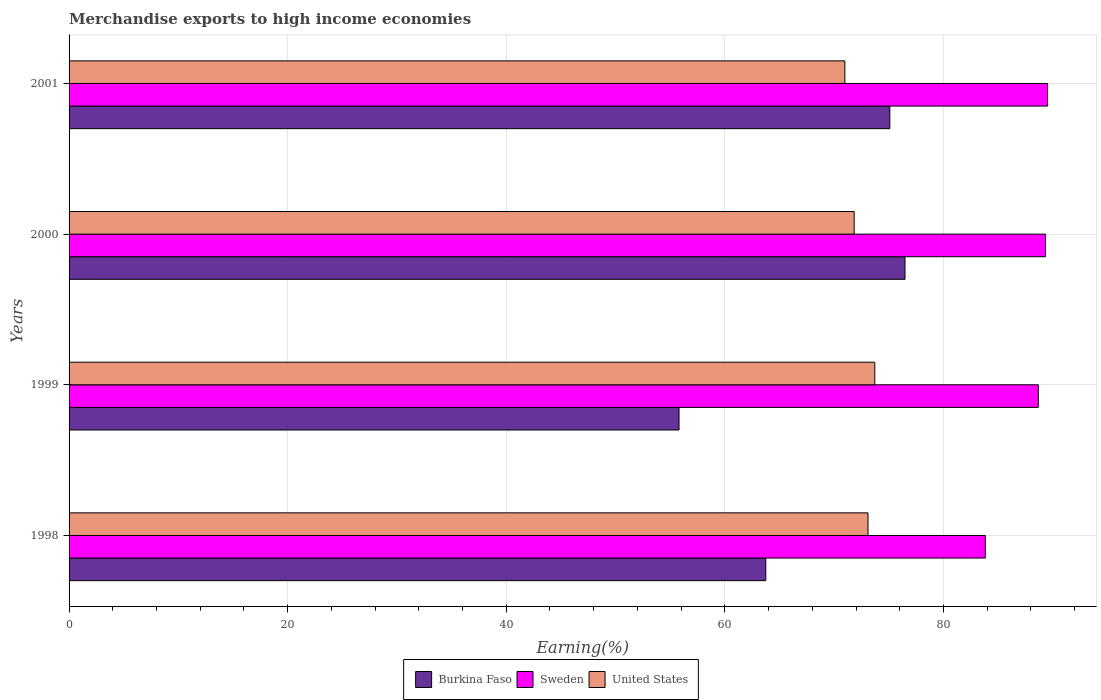What is the label of the 1st group of bars from the top?
Your answer should be very brief. 2001. What is the percentage of amount earned from merchandise exports in United States in 2001?
Give a very brief answer. 70.98. Across all years, what is the maximum percentage of amount earned from merchandise exports in Burkina Faso?
Provide a succinct answer. 76.48. Across all years, what is the minimum percentage of amount earned from merchandise exports in Burkina Faso?
Give a very brief answer. 55.81. In which year was the percentage of amount earned from merchandise exports in Sweden minimum?
Keep it short and to the point. 1998. What is the total percentage of amount earned from merchandise exports in Burkina Faso in the graph?
Give a very brief answer. 271.13. What is the difference between the percentage of amount earned from merchandise exports in United States in 2000 and that in 2001?
Provide a short and direct response. 0.85. What is the difference between the percentage of amount earned from merchandise exports in United States in 2000 and the percentage of amount earned from merchandise exports in Sweden in 2001?
Your answer should be very brief. -17.69. What is the average percentage of amount earned from merchandise exports in Burkina Faso per year?
Keep it short and to the point. 67.78. In the year 2000, what is the difference between the percentage of amount earned from merchandise exports in Burkina Faso and percentage of amount earned from merchandise exports in Sweden?
Offer a very short reply. -12.85. What is the ratio of the percentage of amount earned from merchandise exports in Sweden in 2000 to that in 2001?
Your answer should be compact. 1. Is the percentage of amount earned from merchandise exports in Sweden in 1998 less than that in 1999?
Ensure brevity in your answer.  Yes. Is the difference between the percentage of amount earned from merchandise exports in Burkina Faso in 1998 and 2000 greater than the difference between the percentage of amount earned from merchandise exports in Sweden in 1998 and 2000?
Give a very brief answer. No. What is the difference between the highest and the second highest percentage of amount earned from merchandise exports in Burkina Faso?
Provide a short and direct response. 1.39. What is the difference between the highest and the lowest percentage of amount earned from merchandise exports in Burkina Faso?
Make the answer very short. 20.68. In how many years, is the percentage of amount earned from merchandise exports in Burkina Faso greater than the average percentage of amount earned from merchandise exports in Burkina Faso taken over all years?
Give a very brief answer. 2. What does the 1st bar from the top in 2001 represents?
Keep it short and to the point. United States. What does the 2nd bar from the bottom in 2000 represents?
Offer a very short reply. Sweden. What is the difference between two consecutive major ticks on the X-axis?
Keep it short and to the point. 20. Are the values on the major ticks of X-axis written in scientific E-notation?
Provide a short and direct response. No. How many legend labels are there?
Provide a succinct answer. 3. How are the legend labels stacked?
Offer a terse response. Horizontal. What is the title of the graph?
Ensure brevity in your answer.  Merchandise exports to high income economies. Does "Venezuela" appear as one of the legend labels in the graph?
Your answer should be very brief. No. What is the label or title of the X-axis?
Your response must be concise. Earning(%). What is the Earning(%) in Burkina Faso in 1998?
Provide a succinct answer. 63.75. What is the Earning(%) of Sweden in 1998?
Your response must be concise. 83.83. What is the Earning(%) of United States in 1998?
Provide a short and direct response. 73.1. What is the Earning(%) in Burkina Faso in 1999?
Give a very brief answer. 55.81. What is the Earning(%) of Sweden in 1999?
Ensure brevity in your answer.  88.68. What is the Earning(%) of United States in 1999?
Provide a succinct answer. 73.72. What is the Earning(%) of Burkina Faso in 2000?
Offer a terse response. 76.48. What is the Earning(%) in Sweden in 2000?
Give a very brief answer. 89.33. What is the Earning(%) of United States in 2000?
Your response must be concise. 71.83. What is the Earning(%) of Burkina Faso in 2001?
Provide a short and direct response. 75.09. What is the Earning(%) in Sweden in 2001?
Your response must be concise. 89.53. What is the Earning(%) of United States in 2001?
Offer a terse response. 70.98. Across all years, what is the maximum Earning(%) in Burkina Faso?
Your response must be concise. 76.48. Across all years, what is the maximum Earning(%) in Sweden?
Ensure brevity in your answer.  89.53. Across all years, what is the maximum Earning(%) of United States?
Your answer should be very brief. 73.72. Across all years, what is the minimum Earning(%) of Burkina Faso?
Offer a terse response. 55.81. Across all years, what is the minimum Earning(%) of Sweden?
Ensure brevity in your answer.  83.83. Across all years, what is the minimum Earning(%) in United States?
Give a very brief answer. 70.98. What is the total Earning(%) in Burkina Faso in the graph?
Give a very brief answer. 271.13. What is the total Earning(%) of Sweden in the graph?
Make the answer very short. 351.37. What is the total Earning(%) of United States in the graph?
Your answer should be compact. 289.63. What is the difference between the Earning(%) in Burkina Faso in 1998 and that in 1999?
Your answer should be compact. 7.94. What is the difference between the Earning(%) of Sweden in 1998 and that in 1999?
Provide a succinct answer. -4.84. What is the difference between the Earning(%) in United States in 1998 and that in 1999?
Give a very brief answer. -0.62. What is the difference between the Earning(%) in Burkina Faso in 1998 and that in 2000?
Your response must be concise. -12.74. What is the difference between the Earning(%) in Sweden in 1998 and that in 2000?
Offer a very short reply. -5.5. What is the difference between the Earning(%) of United States in 1998 and that in 2000?
Offer a terse response. 1.26. What is the difference between the Earning(%) of Burkina Faso in 1998 and that in 2001?
Provide a short and direct response. -11.35. What is the difference between the Earning(%) of Sweden in 1998 and that in 2001?
Make the answer very short. -5.69. What is the difference between the Earning(%) in United States in 1998 and that in 2001?
Ensure brevity in your answer.  2.12. What is the difference between the Earning(%) in Burkina Faso in 1999 and that in 2000?
Offer a very short reply. -20.68. What is the difference between the Earning(%) of Sweden in 1999 and that in 2000?
Keep it short and to the point. -0.66. What is the difference between the Earning(%) of United States in 1999 and that in 2000?
Keep it short and to the point. 1.89. What is the difference between the Earning(%) of Burkina Faso in 1999 and that in 2001?
Your response must be concise. -19.29. What is the difference between the Earning(%) of Sweden in 1999 and that in 2001?
Give a very brief answer. -0.85. What is the difference between the Earning(%) of United States in 1999 and that in 2001?
Give a very brief answer. 2.74. What is the difference between the Earning(%) of Burkina Faso in 2000 and that in 2001?
Your answer should be compact. 1.39. What is the difference between the Earning(%) of Sweden in 2000 and that in 2001?
Give a very brief answer. -0.19. What is the difference between the Earning(%) of United States in 2000 and that in 2001?
Give a very brief answer. 0.85. What is the difference between the Earning(%) of Burkina Faso in 1998 and the Earning(%) of Sweden in 1999?
Make the answer very short. -24.93. What is the difference between the Earning(%) in Burkina Faso in 1998 and the Earning(%) in United States in 1999?
Your answer should be very brief. -9.97. What is the difference between the Earning(%) in Sweden in 1998 and the Earning(%) in United States in 1999?
Ensure brevity in your answer.  10.11. What is the difference between the Earning(%) in Burkina Faso in 1998 and the Earning(%) in Sweden in 2000?
Keep it short and to the point. -25.59. What is the difference between the Earning(%) of Burkina Faso in 1998 and the Earning(%) of United States in 2000?
Your response must be concise. -8.09. What is the difference between the Earning(%) of Sweden in 1998 and the Earning(%) of United States in 2000?
Keep it short and to the point. 12. What is the difference between the Earning(%) in Burkina Faso in 1998 and the Earning(%) in Sweden in 2001?
Give a very brief answer. -25.78. What is the difference between the Earning(%) in Burkina Faso in 1998 and the Earning(%) in United States in 2001?
Provide a succinct answer. -7.23. What is the difference between the Earning(%) in Sweden in 1998 and the Earning(%) in United States in 2001?
Keep it short and to the point. 12.85. What is the difference between the Earning(%) in Burkina Faso in 1999 and the Earning(%) in Sweden in 2000?
Offer a terse response. -33.53. What is the difference between the Earning(%) of Burkina Faso in 1999 and the Earning(%) of United States in 2000?
Your answer should be very brief. -16.02. What is the difference between the Earning(%) in Sweden in 1999 and the Earning(%) in United States in 2000?
Keep it short and to the point. 16.84. What is the difference between the Earning(%) in Burkina Faso in 1999 and the Earning(%) in Sweden in 2001?
Provide a succinct answer. -33.72. What is the difference between the Earning(%) in Burkina Faso in 1999 and the Earning(%) in United States in 2001?
Provide a short and direct response. -15.17. What is the difference between the Earning(%) of Sweden in 1999 and the Earning(%) of United States in 2001?
Your answer should be compact. 17.7. What is the difference between the Earning(%) in Burkina Faso in 2000 and the Earning(%) in Sweden in 2001?
Keep it short and to the point. -13.04. What is the difference between the Earning(%) of Burkina Faso in 2000 and the Earning(%) of United States in 2001?
Make the answer very short. 5.5. What is the difference between the Earning(%) of Sweden in 2000 and the Earning(%) of United States in 2001?
Provide a succinct answer. 18.35. What is the average Earning(%) of Burkina Faso per year?
Your answer should be very brief. 67.78. What is the average Earning(%) in Sweden per year?
Ensure brevity in your answer.  87.84. What is the average Earning(%) in United States per year?
Offer a very short reply. 72.41. In the year 1998, what is the difference between the Earning(%) of Burkina Faso and Earning(%) of Sweden?
Ensure brevity in your answer.  -20.09. In the year 1998, what is the difference between the Earning(%) of Burkina Faso and Earning(%) of United States?
Provide a short and direct response. -9.35. In the year 1998, what is the difference between the Earning(%) of Sweden and Earning(%) of United States?
Your answer should be compact. 10.74. In the year 1999, what is the difference between the Earning(%) in Burkina Faso and Earning(%) in Sweden?
Provide a succinct answer. -32.87. In the year 1999, what is the difference between the Earning(%) in Burkina Faso and Earning(%) in United States?
Your answer should be compact. -17.91. In the year 1999, what is the difference between the Earning(%) in Sweden and Earning(%) in United States?
Give a very brief answer. 14.96. In the year 2000, what is the difference between the Earning(%) in Burkina Faso and Earning(%) in Sweden?
Give a very brief answer. -12.85. In the year 2000, what is the difference between the Earning(%) in Burkina Faso and Earning(%) in United States?
Make the answer very short. 4.65. In the year 2000, what is the difference between the Earning(%) of Sweden and Earning(%) of United States?
Give a very brief answer. 17.5. In the year 2001, what is the difference between the Earning(%) in Burkina Faso and Earning(%) in Sweden?
Your response must be concise. -14.43. In the year 2001, what is the difference between the Earning(%) in Burkina Faso and Earning(%) in United States?
Your answer should be very brief. 4.11. In the year 2001, what is the difference between the Earning(%) in Sweden and Earning(%) in United States?
Offer a terse response. 18.55. What is the ratio of the Earning(%) in Burkina Faso in 1998 to that in 1999?
Offer a very short reply. 1.14. What is the ratio of the Earning(%) of Sweden in 1998 to that in 1999?
Ensure brevity in your answer.  0.95. What is the ratio of the Earning(%) of Burkina Faso in 1998 to that in 2000?
Your response must be concise. 0.83. What is the ratio of the Earning(%) of Sweden in 1998 to that in 2000?
Provide a succinct answer. 0.94. What is the ratio of the Earning(%) in United States in 1998 to that in 2000?
Provide a succinct answer. 1.02. What is the ratio of the Earning(%) in Burkina Faso in 1998 to that in 2001?
Keep it short and to the point. 0.85. What is the ratio of the Earning(%) of Sweden in 1998 to that in 2001?
Your answer should be compact. 0.94. What is the ratio of the Earning(%) in United States in 1998 to that in 2001?
Your answer should be very brief. 1.03. What is the ratio of the Earning(%) of Burkina Faso in 1999 to that in 2000?
Offer a terse response. 0.73. What is the ratio of the Earning(%) in Sweden in 1999 to that in 2000?
Provide a short and direct response. 0.99. What is the ratio of the Earning(%) in United States in 1999 to that in 2000?
Your answer should be very brief. 1.03. What is the ratio of the Earning(%) of Burkina Faso in 1999 to that in 2001?
Provide a succinct answer. 0.74. What is the ratio of the Earning(%) in United States in 1999 to that in 2001?
Make the answer very short. 1.04. What is the ratio of the Earning(%) of Burkina Faso in 2000 to that in 2001?
Provide a succinct answer. 1.02. What is the ratio of the Earning(%) of Sweden in 2000 to that in 2001?
Give a very brief answer. 1. What is the ratio of the Earning(%) of United States in 2000 to that in 2001?
Your answer should be compact. 1.01. What is the difference between the highest and the second highest Earning(%) of Burkina Faso?
Provide a short and direct response. 1.39. What is the difference between the highest and the second highest Earning(%) of Sweden?
Keep it short and to the point. 0.19. What is the difference between the highest and the second highest Earning(%) in United States?
Make the answer very short. 0.62. What is the difference between the highest and the lowest Earning(%) of Burkina Faso?
Provide a short and direct response. 20.68. What is the difference between the highest and the lowest Earning(%) in Sweden?
Offer a terse response. 5.69. What is the difference between the highest and the lowest Earning(%) in United States?
Ensure brevity in your answer.  2.74. 